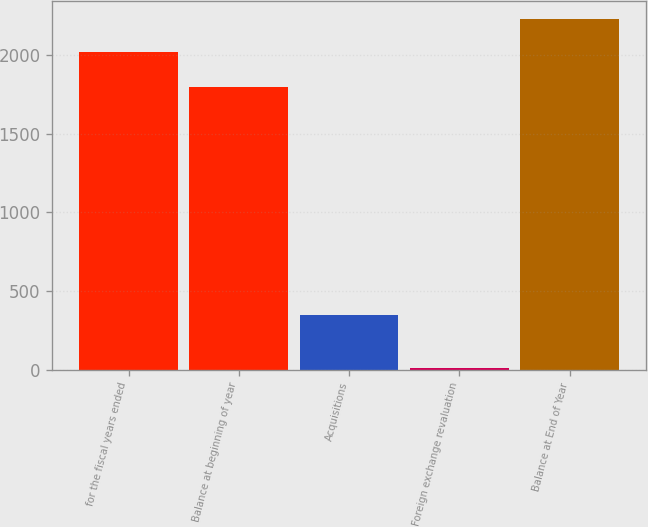Convert chart to OTSL. <chart><loc_0><loc_0><loc_500><loc_500><bar_chart><fcel>for the fiscal years ended<fcel>Balance at beginning of year<fcel>Acquisitions<fcel>Foreign exchange revaluation<fcel>Balance at End of Year<nl><fcel>2019<fcel>1794.8<fcel>345.7<fcel>10.2<fcel>2231.01<nl></chart> 